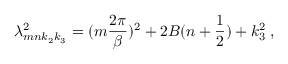Convert formula to latex. <formula><loc_0><loc_0><loc_500><loc_500>\lambda _ { m n k _ { 2 } k _ { 3 } } ^ { 2 } = ( m \frac { 2 \pi } { \beta } ) ^ { 2 } + 2 B ( n + \frac { 1 } { 2 } ) + k _ { 3 } ^ { 2 } \, ,</formula> 